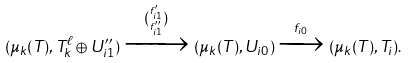<formula> <loc_0><loc_0><loc_500><loc_500>( \mu _ { k } ( T ) , T _ { k } ^ { \ell } \oplus U ^ { \prime \prime } _ { i 1 } ) \xrightarrow { { f ^ { \prime } _ { i 1 } \choose f ^ { \prime \prime } _ { i 1 } } } ( \mu _ { k } ( T ) , U _ { i 0 } ) \xrightarrow { f _ { i 0 } } ( \mu _ { k } ( T ) , T _ { i } ) .</formula> 